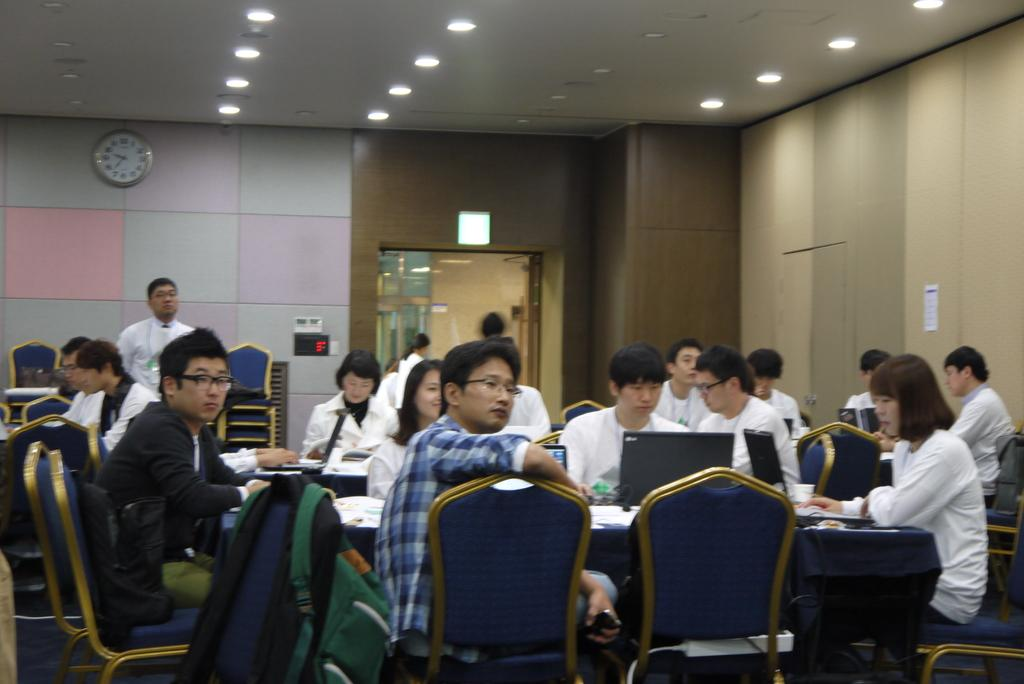How many people are in the image? There is a group of persons in the image, but the exact number is not specified. What are the people in the image doing? The group of persons is sitting in front of a table. What can be seen on the table? The table has laptops on it. What is hanging on the wall in the background of the image? There is a watch attached to the wall in the background of the image. What type of moon can be seen in the image? There is no moon present in the image. Can you tell me how many calculators are on the table in the image? There is no calculator present on the table in the image; only laptops are visible. 